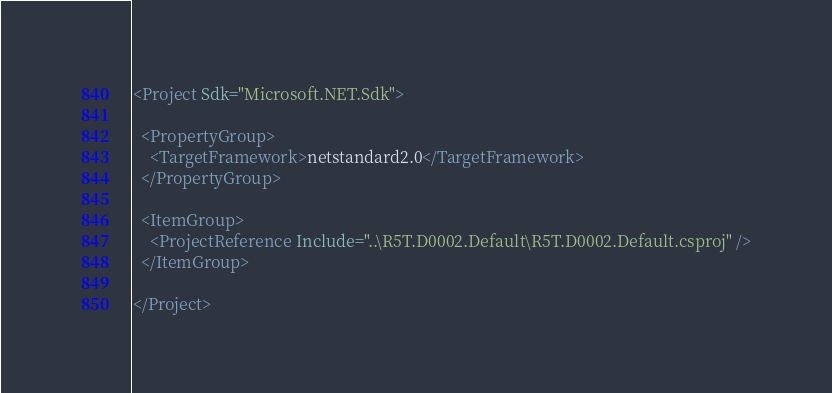<code> <loc_0><loc_0><loc_500><loc_500><_XML_><Project Sdk="Microsoft.NET.Sdk">

  <PropertyGroup>
    <TargetFramework>netstandard2.0</TargetFramework>
  </PropertyGroup>

  <ItemGroup>
    <ProjectReference Include="..\R5T.D0002.Default\R5T.D0002.Default.csproj" />
  </ItemGroup>

</Project>
</code> 